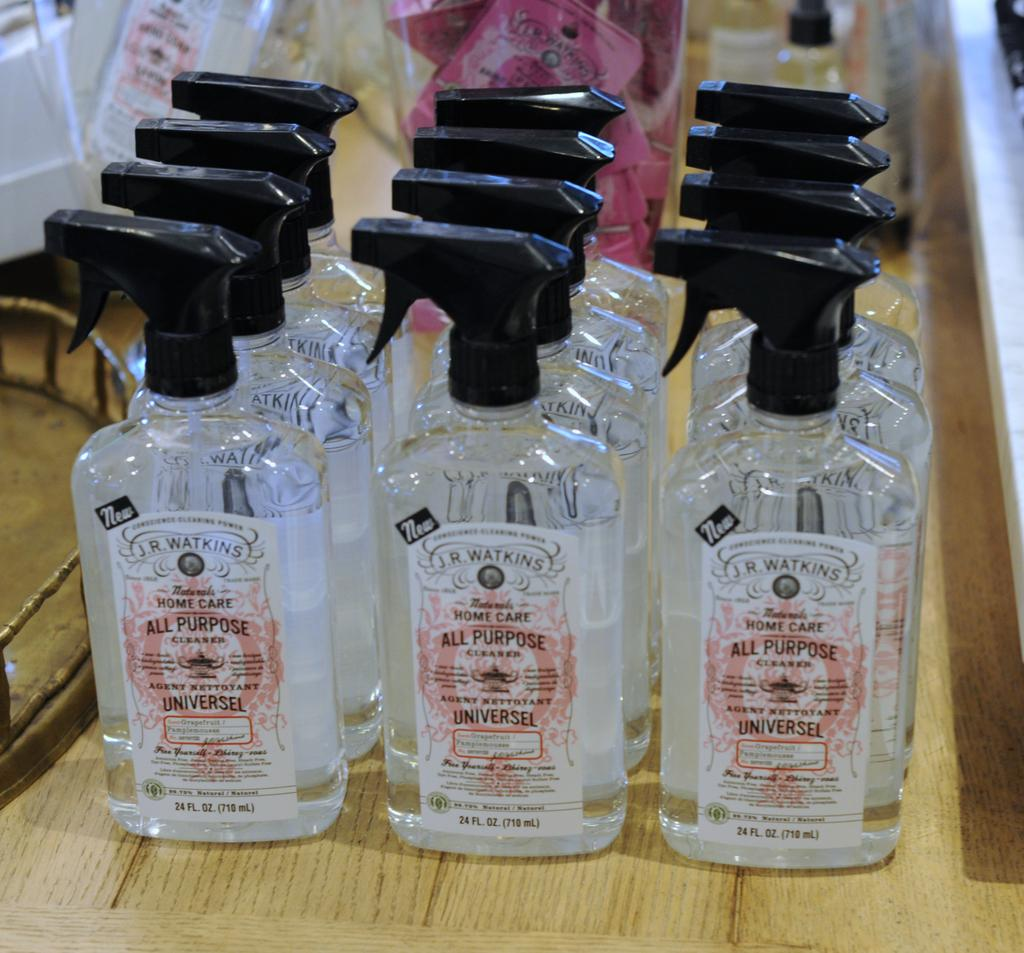<image>
Present a compact description of the photo's key features. A group of twelve bottles of all purpose cleaner 